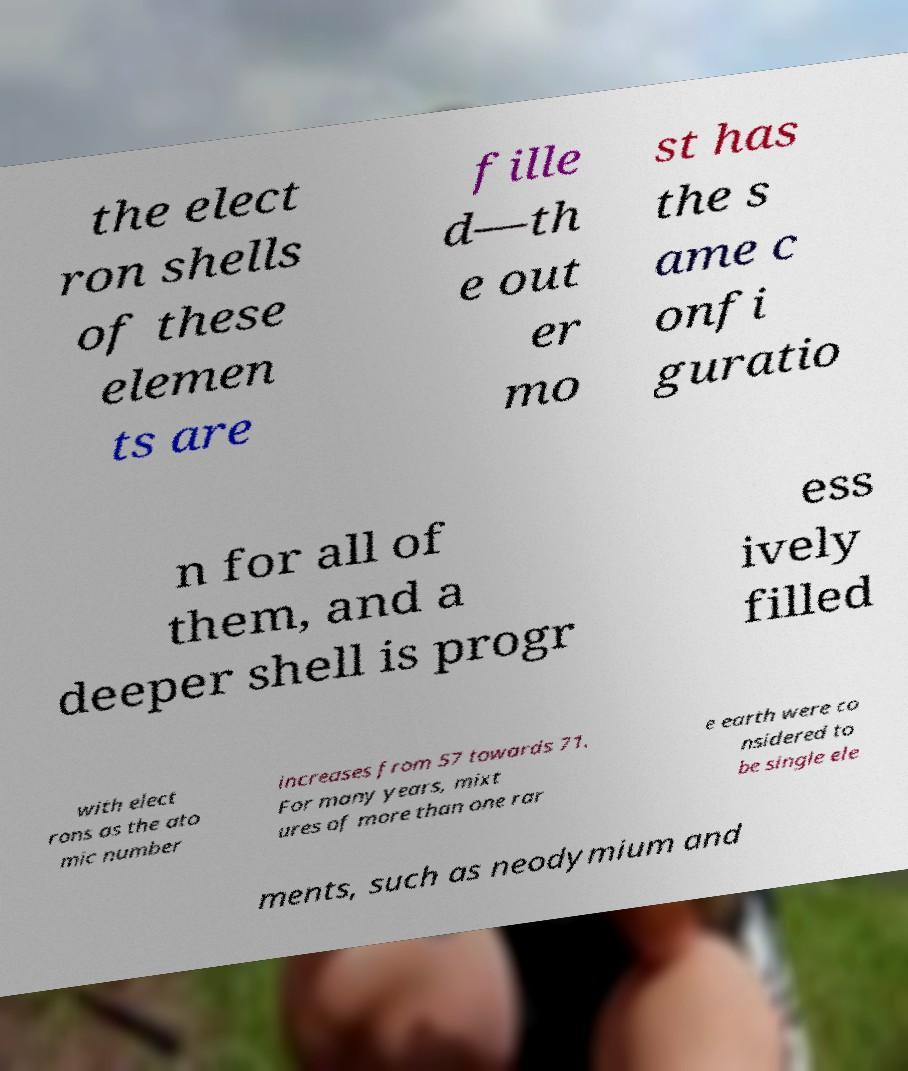Can you accurately transcribe the text from the provided image for me? the elect ron shells of these elemen ts are fille d—th e out er mo st has the s ame c onfi guratio n for all of them, and a deeper shell is progr ess ively filled with elect rons as the ato mic number increases from 57 towards 71. For many years, mixt ures of more than one rar e earth were co nsidered to be single ele ments, such as neodymium and 